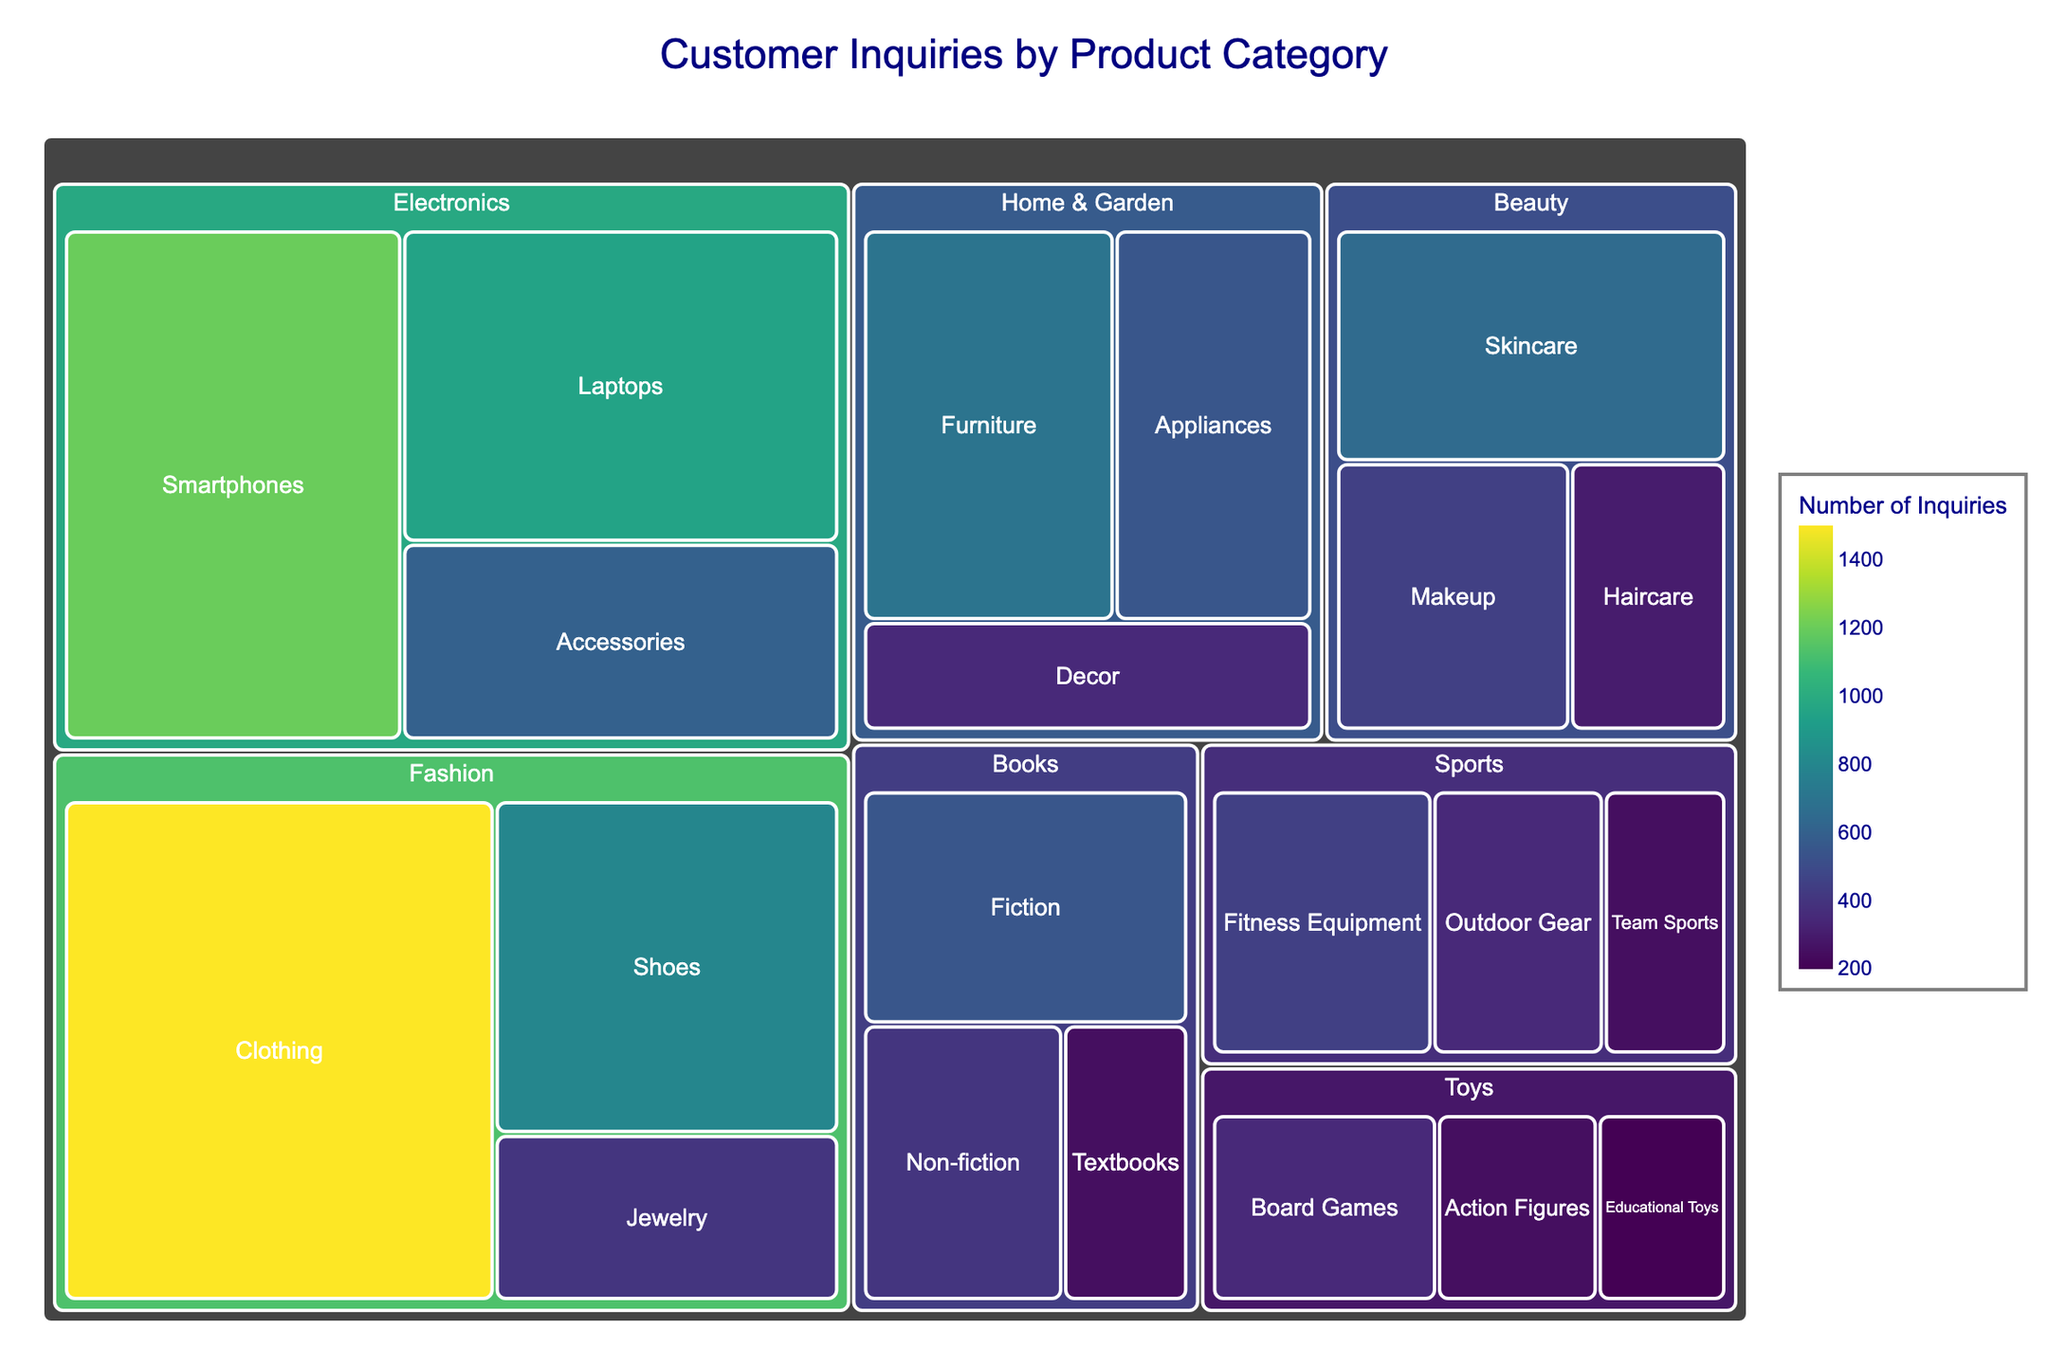What is the title of the figure? The title is located at the top of the figure and usually describes the content or purpose of the visual representation.
Answer: Customer Inquiries by Product Category Which product category received the highest number of customer inquiries? You need to look for the largest segment and the one with the highest value in the treemap.
Answer: Fashion How many inquiries did the 'Books' category receive in total? Add up the inquiries from all subcategories within 'Books': Fiction, Non-fiction, and Textbooks (550 + 400 + 250)
Answer: 1200 Compare the number of inquiries between 'Skincare' and 'Makeup' subcategories. Which one received more and by how much? Identify the inquiries for both subcategories: Skincare (650) and Makeup (450), then calculate the difference (650 - 450)
Answer: Skincare received 200 more Which subcategory in 'Home & Garden' has the fewest customer inquiries? Look at the subcategories within 'Home & Garden' and find the one with the least inquiries: Furniture (700), Appliances (550), Decor (350)
Answer: Decor What is the average number of inquiries among the subcategories in the 'Sports' category? Add the inquiries in 'Sports' (Fitness Equipment: 450, Outdoor Gear: 350, Team Sports: 250) and divide by the number of subcategories (3). (450 + 350 + 250) / 3
Answer: 350 Which two categories have subcategories with exactly 250 inquiries each? Identify subcategories with 250 inquiries and see which categories they belong to; 'Books' (Textbooks) and 'Toys' (Action Figures, Educational Toys)
Answer: Books, Toys What is the total number of inquiries for the 'Electronics' category? Sum the inquiries from all subcategories within 'Electronics': Smartphones (1200), Laptops (950), Accessories (600) (1200 + 950 + 600)
Answer: 2750 Which category has more inquiries, 'Beauty' or 'Toys', and by how much? Sum the inquiries for 'Beauty' (Skincare: 650, Makeup: 450, Haircare: 300) and 'Toys' (Board Games: 350, Action Figures: 250, Educational Toys: 200), then compare the totals (650+450+300) - (350+250+200)
Answer: Beauty by 600 What is the ratio of inquiries between 'Clothing' in 'Fashion' and 'Laptops' in 'Electronics'? Obtain the number of inquiries for Clothing (1500) and Laptops (950) and divide Clothing by Laptops: 1500 / 950
Answer: 1.58 